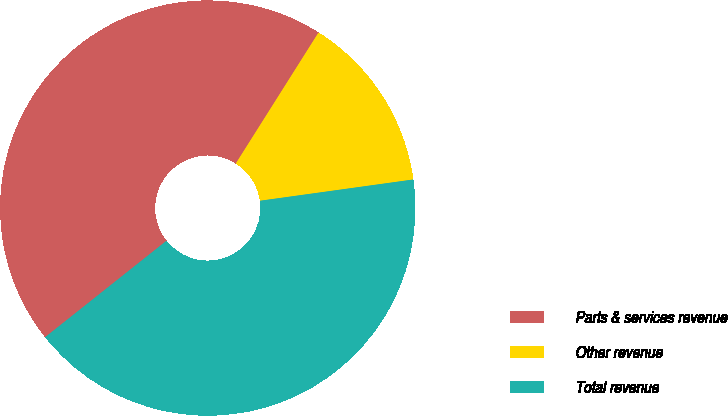<chart> <loc_0><loc_0><loc_500><loc_500><pie_chart><fcel>Parts & services revenue<fcel>Other revenue<fcel>Total revenue<nl><fcel>44.65%<fcel>13.84%<fcel>41.51%<nl></chart> 